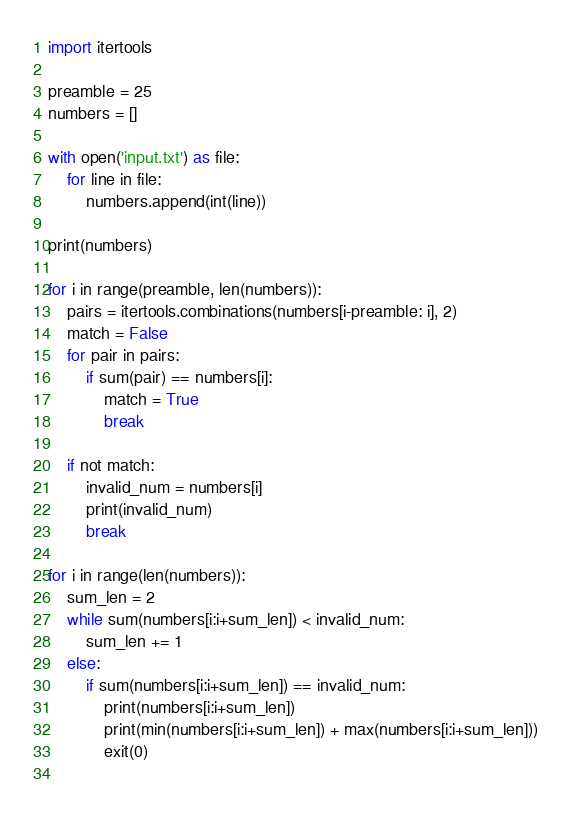<code> <loc_0><loc_0><loc_500><loc_500><_Python_>import itertools

preamble = 25
numbers = []

with open('input.txt') as file:
    for line in file:
        numbers.append(int(line))

print(numbers)

for i in range(preamble, len(numbers)):
    pairs = itertools.combinations(numbers[i-preamble: i], 2)
    match = False
    for pair in pairs:
        if sum(pair) == numbers[i]:
            match = True
            break
    
    if not match:
        invalid_num = numbers[i]
        print(invalid_num)
        break

for i in range(len(numbers)):
    sum_len = 2
    while sum(numbers[i:i+sum_len]) < invalid_num:
        sum_len += 1
    else:
        if sum(numbers[i:i+sum_len]) == invalid_num:
            print(numbers[i:i+sum_len])
            print(min(numbers[i:i+sum_len]) + max(numbers[i:i+sum_len]))
            exit(0)
    

</code> 